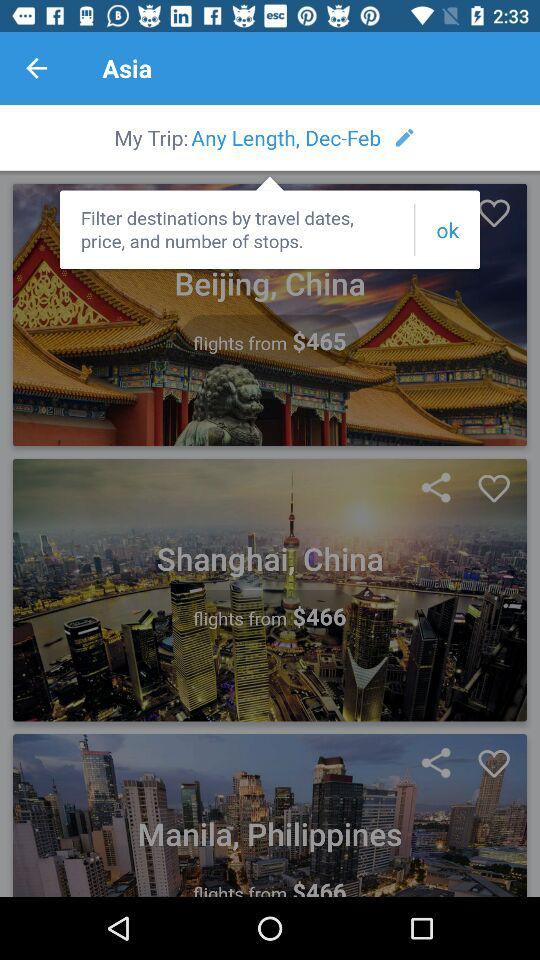What is the price of a flight ticket to Shanghai, China? The price of a flight ticket to Shanghai, China, starts from $466. 